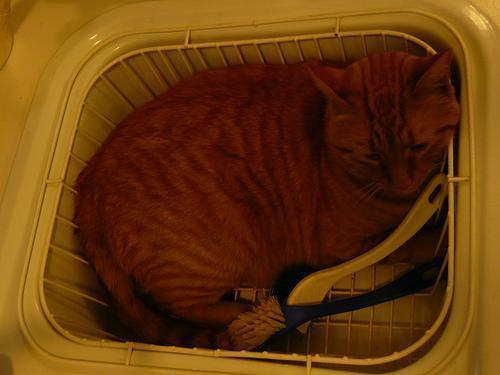How many legs does the cat have?
Give a very brief answer. 4. How many brushes are in the photo?
Give a very brief answer. 2. 